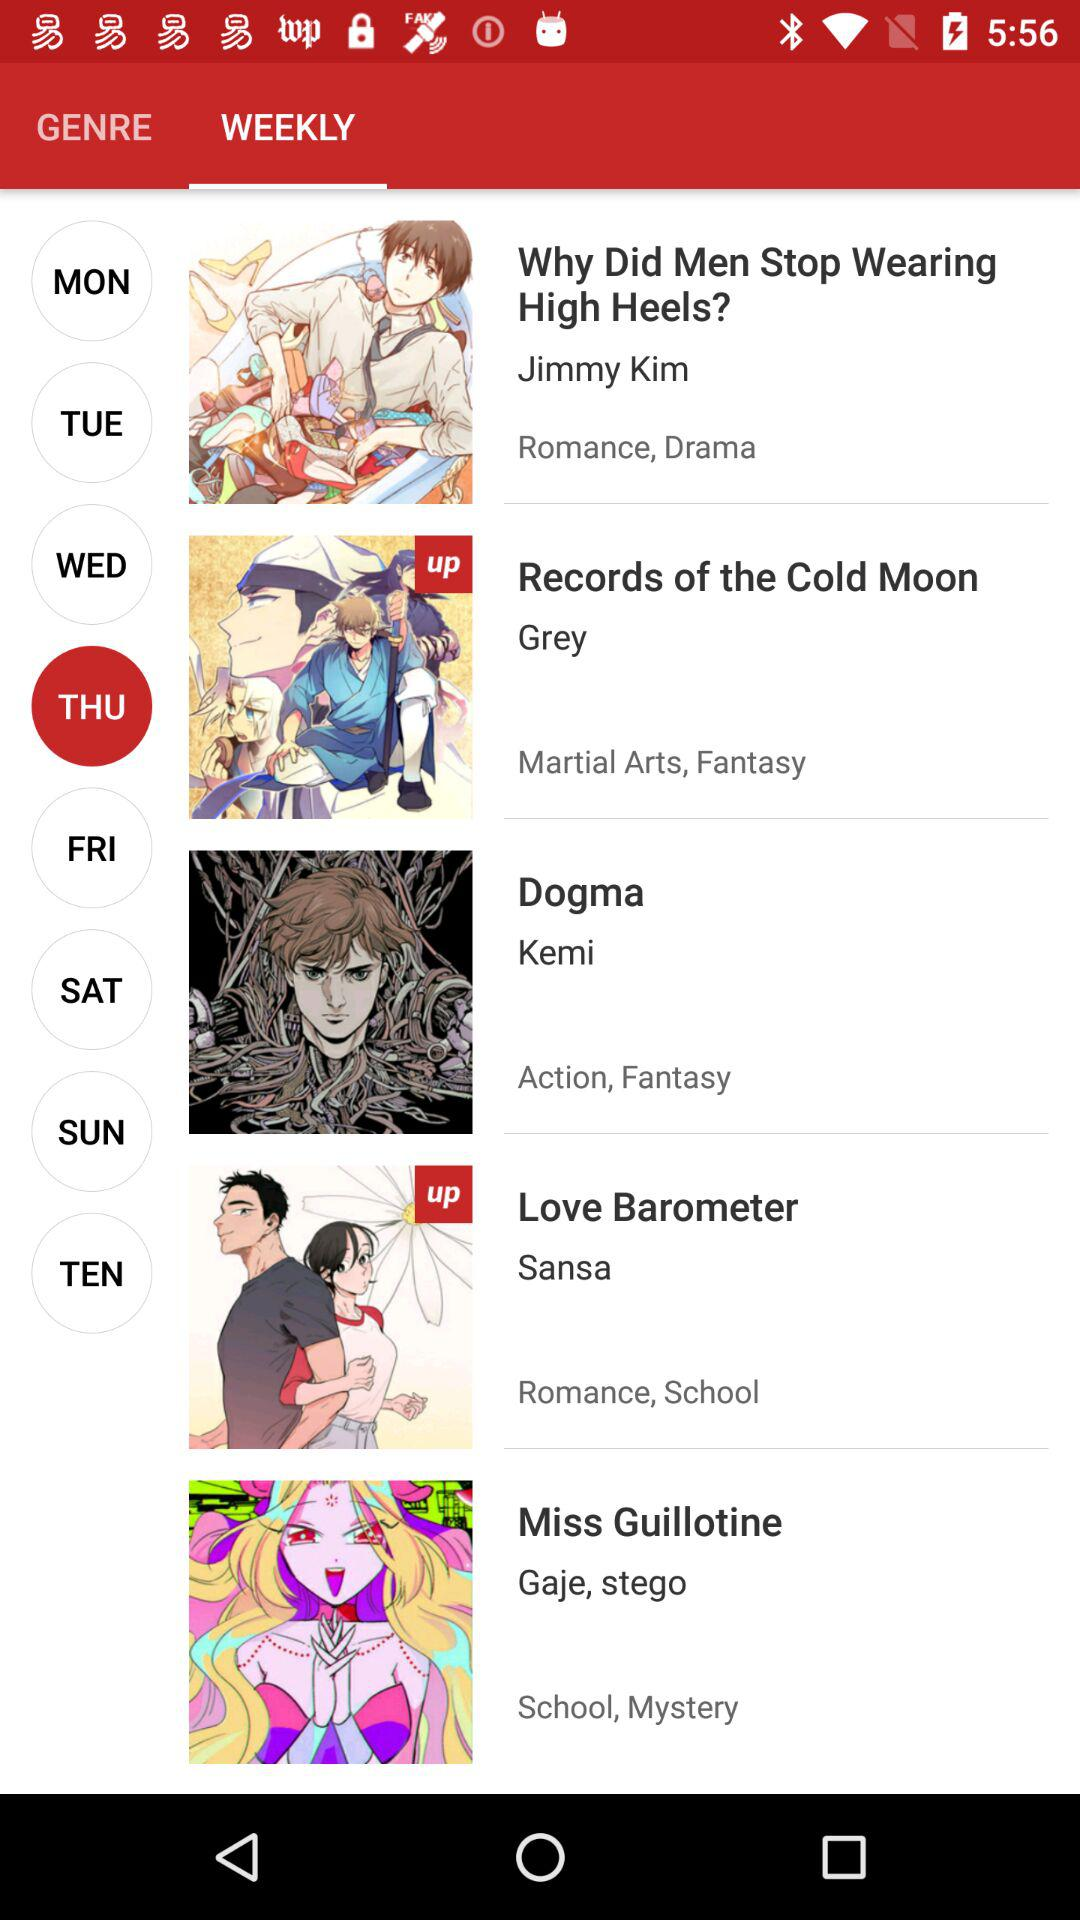What is the selected day? The selected day is Thursday. 